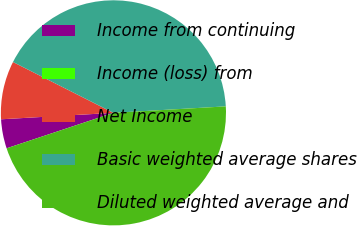Convert chart. <chart><loc_0><loc_0><loc_500><loc_500><pie_chart><fcel>Income from continuing<fcel>Income (loss) from<fcel>Net Income<fcel>Basic weighted average shares<fcel>Diluted weighted average and<nl><fcel>4.19%<fcel>0.0%<fcel>8.37%<fcel>41.63%<fcel>45.81%<nl></chart> 